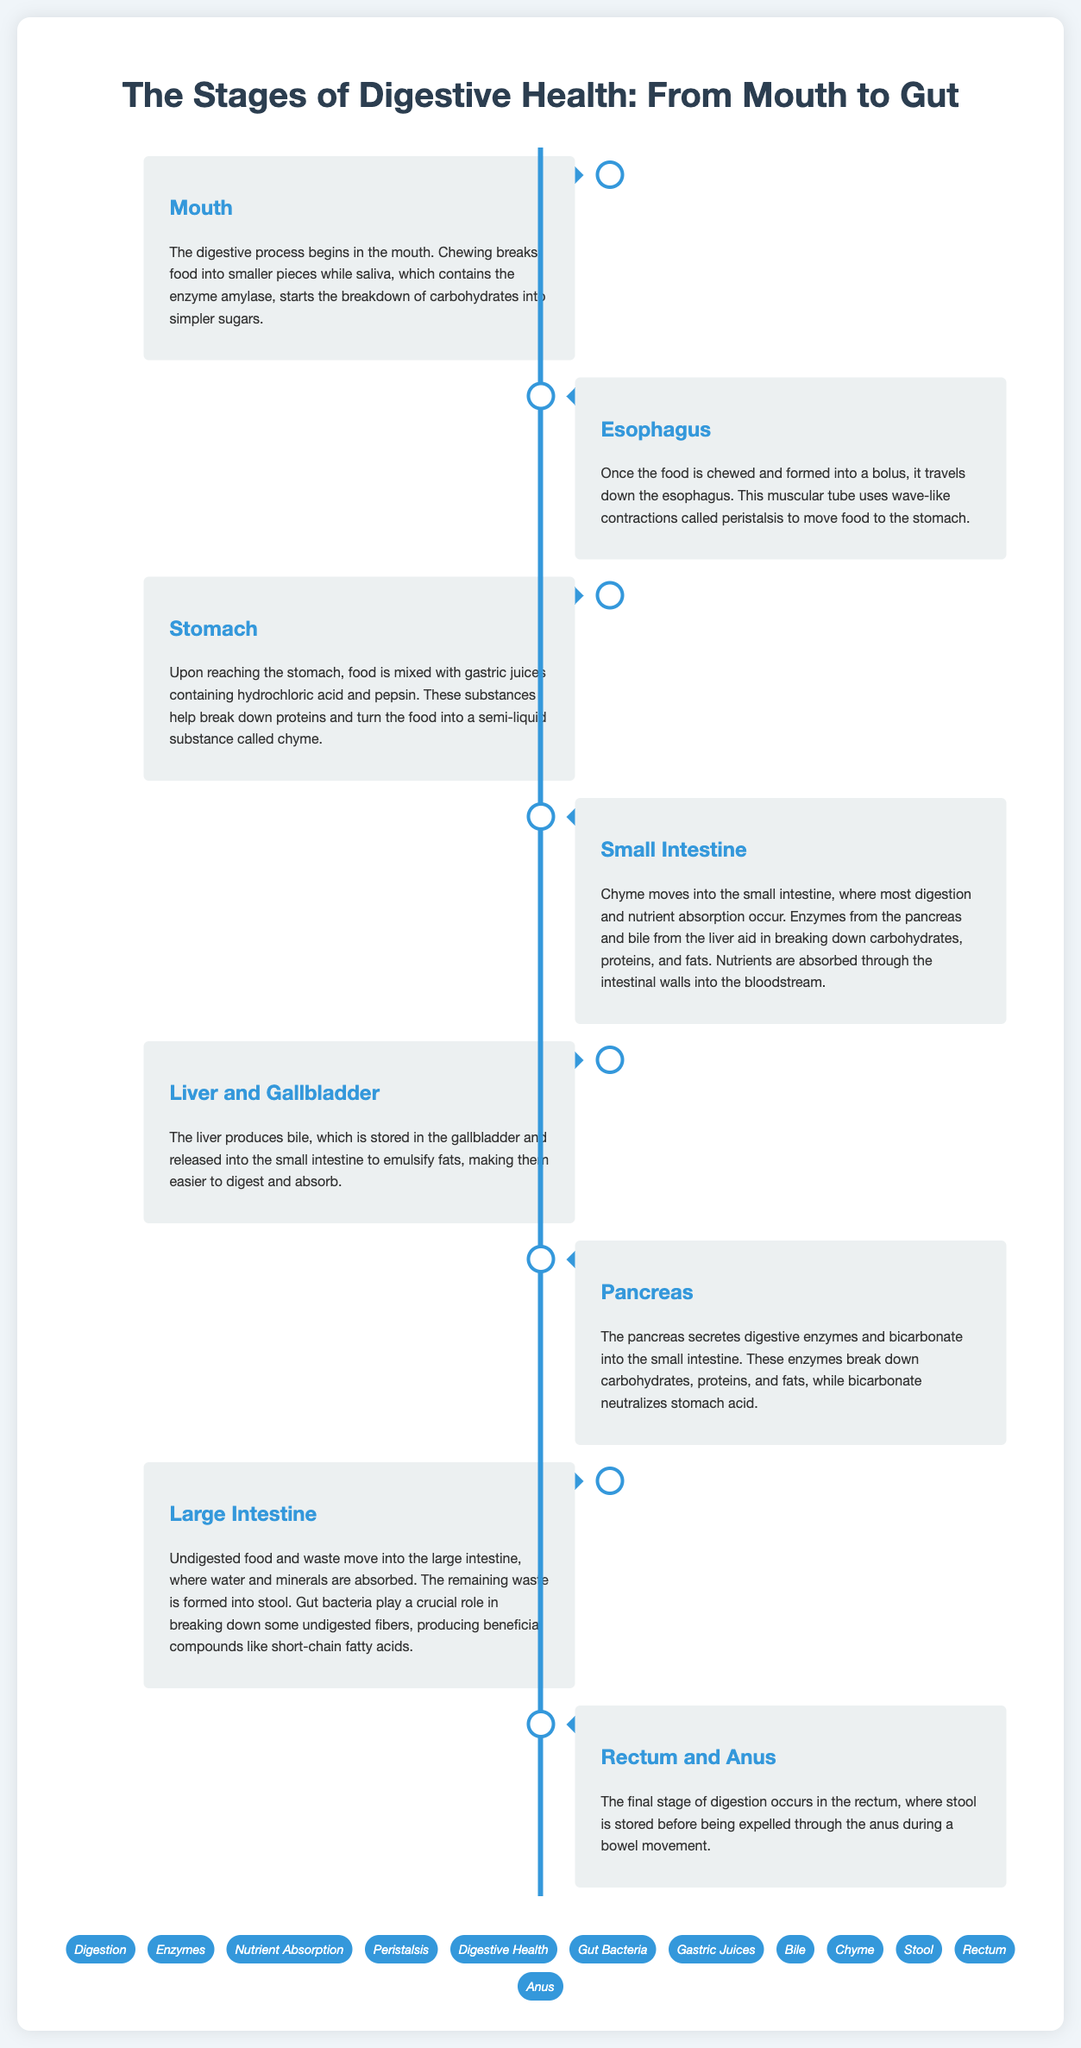What is the first stage of digestion? The first stage of digestion as per the document is the mouth, where food begins to be broken down.
Answer: Mouth What enzyme starts the breakdown of carbohydrates? The document states that amylase is the enzyme in saliva that starts the breakdown of carbohydrates.
Answer: Amylase What role do gastric juices play in the stomach? Gastric juices, containing hydrochloric acid and pepsin, break down proteins and turn the food into a semi-liquid substance called chyme.
Answer: Break down proteins Which organ is responsible for producing bile? According to the document, the liver is responsible for producing bile.
Answer: Liver What happens to water and minerals in the large intestine? The large intestine absorbs water and minerals from undigested food before waste is formed into stool.
Answer: Absorbed How many main digestive organs are mentioned in the document? The document lists eight main digestive organs involved in the digestive process.
Answer: Eight What is the function of bile in the small intestine? The document notes that bile emulsifies fats, making them easier to digest and absorb in the small intestine.
Answer: Emulsify fats What is the term for the wave-like contractions that move food through the esophagus? The document describes these contractions as peristalsis, which helps move food to the stomach.
Answer: Peristalsis What is formed in the large intestine? The final stage of processing undigested food in the large intestine is forming stool.
Answer: Stool 